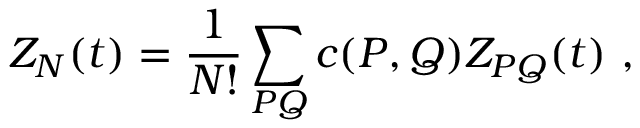<formula> <loc_0><loc_0><loc_500><loc_500>Z _ { N } ( t ) = { \frac { 1 } { N ! } } \sum _ { P Q } c ( P , Q ) Z _ { P Q } ( t ) ,</formula> 